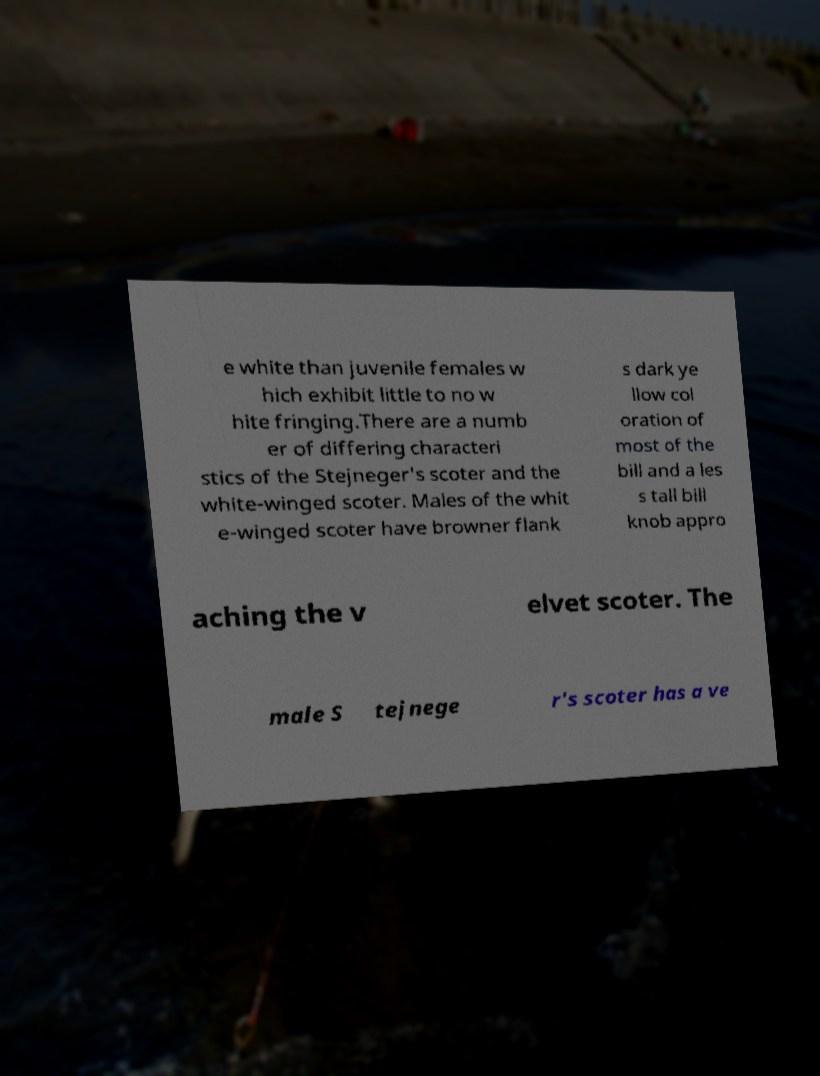Could you extract and type out the text from this image? e white than juvenile females w hich exhibit little to no w hite fringing.There are a numb er of differing characteri stics of the Stejneger's scoter and the white-winged scoter. Males of the whit e-winged scoter have browner flank s dark ye llow col oration of most of the bill and a les s tall bill knob appro aching the v elvet scoter. The male S tejnege r's scoter has a ve 